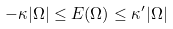Convert formula to latex. <formula><loc_0><loc_0><loc_500><loc_500>- \kappa | \Omega | \leq E ( \Omega ) \leq \kappa ^ { \prime } | \Omega |</formula> 